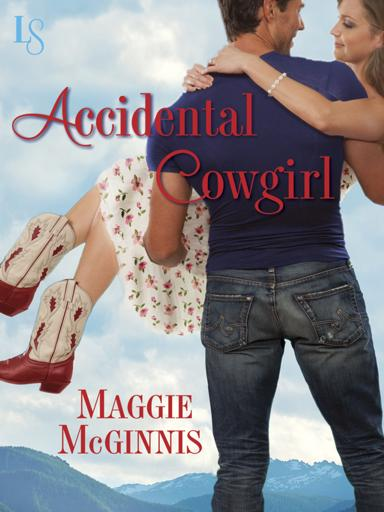Describe the setting in which the man and woman are hugging. The man and woman are intimately hugging in a serene, picturesque mountain landscape. The backdrop features lush greenery and distant peaks under a clear blue sky, suggesting a peaceful, romantic setting ideal for such a heartfelt moment. 